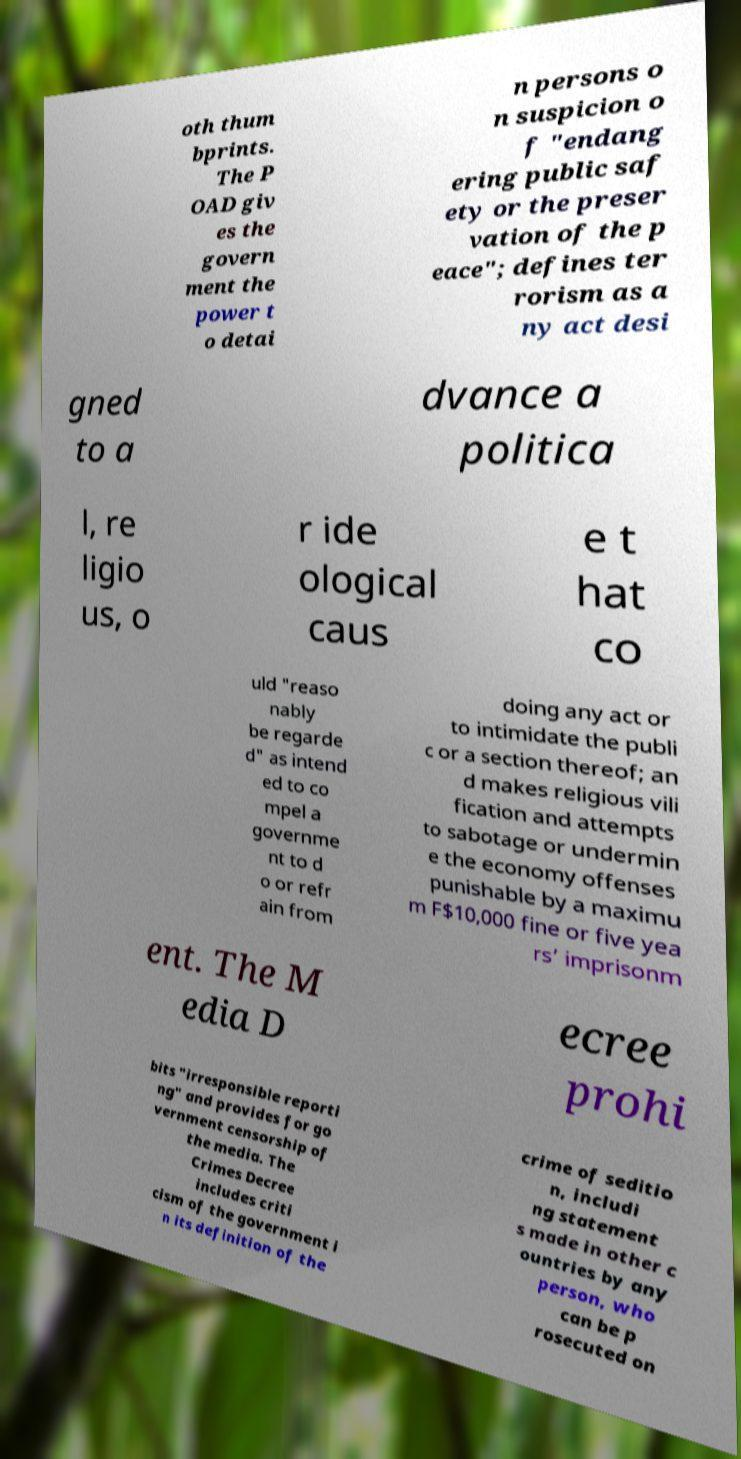Can you read and provide the text displayed in the image?This photo seems to have some interesting text. Can you extract and type it out for me? oth thum bprints. The P OAD giv es the govern ment the power t o detai n persons o n suspicion o f "endang ering public saf ety or the preser vation of the p eace"; defines ter rorism as a ny act desi gned to a dvance a politica l, re ligio us, o r ide ological caus e t hat co uld "reaso nably be regarde d" as intend ed to co mpel a governme nt to d o or refr ain from doing any act or to intimidate the publi c or a section thereof; an d makes religious vili fication and attempts to sabotage or undermin e the economy offenses punishable by a maximu m F$10,000 fine or five yea rs’ imprisonm ent. The M edia D ecree prohi bits "irresponsible reporti ng" and provides for go vernment censorship of the media. The Crimes Decree includes criti cism of the government i n its definition of the crime of seditio n, includi ng statement s made in other c ountries by any person, who can be p rosecuted on 